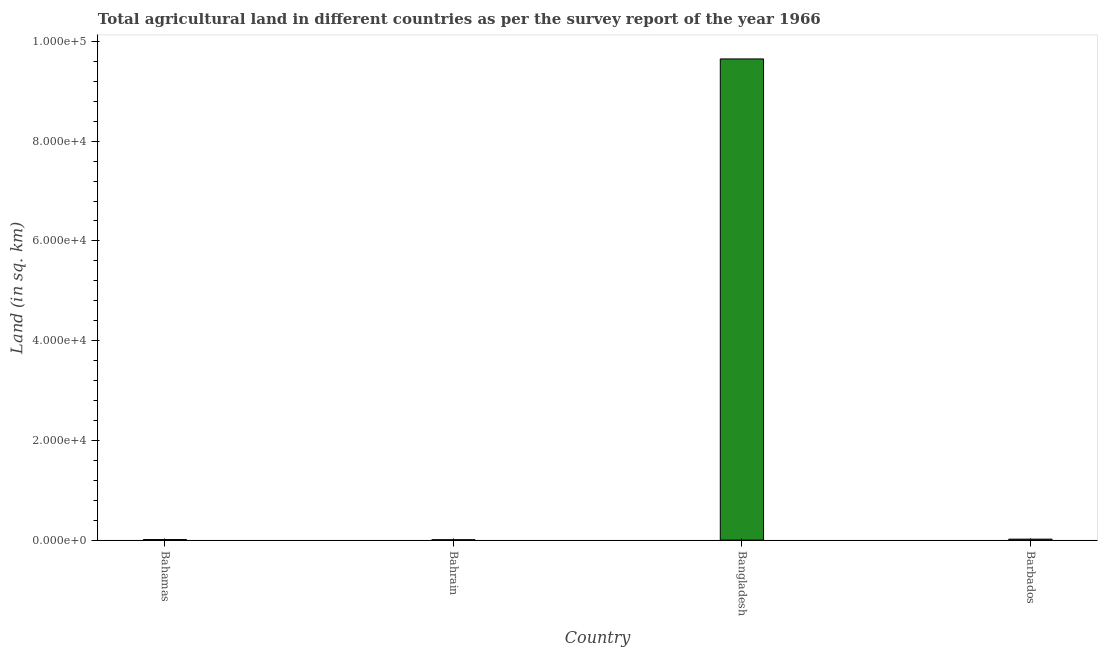Does the graph contain any zero values?
Ensure brevity in your answer.  No. Does the graph contain grids?
Offer a terse response. No. What is the title of the graph?
Offer a very short reply. Total agricultural land in different countries as per the survey report of the year 1966. What is the label or title of the Y-axis?
Provide a succinct answer. Land (in sq. km). What is the agricultural land in Bahamas?
Your response must be concise. 100. Across all countries, what is the maximum agricultural land?
Give a very brief answer. 9.65e+04. In which country was the agricultural land minimum?
Your answer should be compact. Bahrain. What is the sum of the agricultural land?
Give a very brief answer. 9.69e+04. What is the difference between the agricultural land in Bahrain and Barbados?
Offer a terse response. -120. What is the average agricultural land per country?
Keep it short and to the point. 2.42e+04. What is the median agricultural land?
Ensure brevity in your answer.  145. In how many countries, is the agricultural land greater than 24000 sq. km?
Ensure brevity in your answer.  1. What is the ratio of the agricultural land in Bahrain to that in Barbados?
Offer a very short reply. 0.37. What is the difference between the highest and the second highest agricultural land?
Your answer should be very brief. 9.63e+04. What is the difference between the highest and the lowest agricultural land?
Ensure brevity in your answer.  9.64e+04. In how many countries, is the agricultural land greater than the average agricultural land taken over all countries?
Your answer should be very brief. 1. Are all the bars in the graph horizontal?
Provide a succinct answer. No. How many countries are there in the graph?
Offer a terse response. 4. What is the Land (in sq. km) in Bahamas?
Ensure brevity in your answer.  100. What is the Land (in sq. km) of Bahrain?
Give a very brief answer. 70. What is the Land (in sq. km) of Bangladesh?
Your answer should be very brief. 9.65e+04. What is the Land (in sq. km) of Barbados?
Offer a terse response. 190. What is the difference between the Land (in sq. km) in Bahamas and Bangladesh?
Offer a very short reply. -9.64e+04. What is the difference between the Land (in sq. km) in Bahamas and Barbados?
Your answer should be compact. -90. What is the difference between the Land (in sq. km) in Bahrain and Bangladesh?
Provide a short and direct response. -9.64e+04. What is the difference between the Land (in sq. km) in Bahrain and Barbados?
Your answer should be compact. -120. What is the difference between the Land (in sq. km) in Bangladesh and Barbados?
Your response must be concise. 9.63e+04. What is the ratio of the Land (in sq. km) in Bahamas to that in Bahrain?
Offer a very short reply. 1.43. What is the ratio of the Land (in sq. km) in Bahamas to that in Bangladesh?
Offer a terse response. 0. What is the ratio of the Land (in sq. km) in Bahamas to that in Barbados?
Give a very brief answer. 0.53. What is the ratio of the Land (in sq. km) in Bahrain to that in Bangladesh?
Provide a short and direct response. 0. What is the ratio of the Land (in sq. km) in Bahrain to that in Barbados?
Your response must be concise. 0.37. What is the ratio of the Land (in sq. km) in Bangladesh to that in Barbados?
Keep it short and to the point. 507.89. 